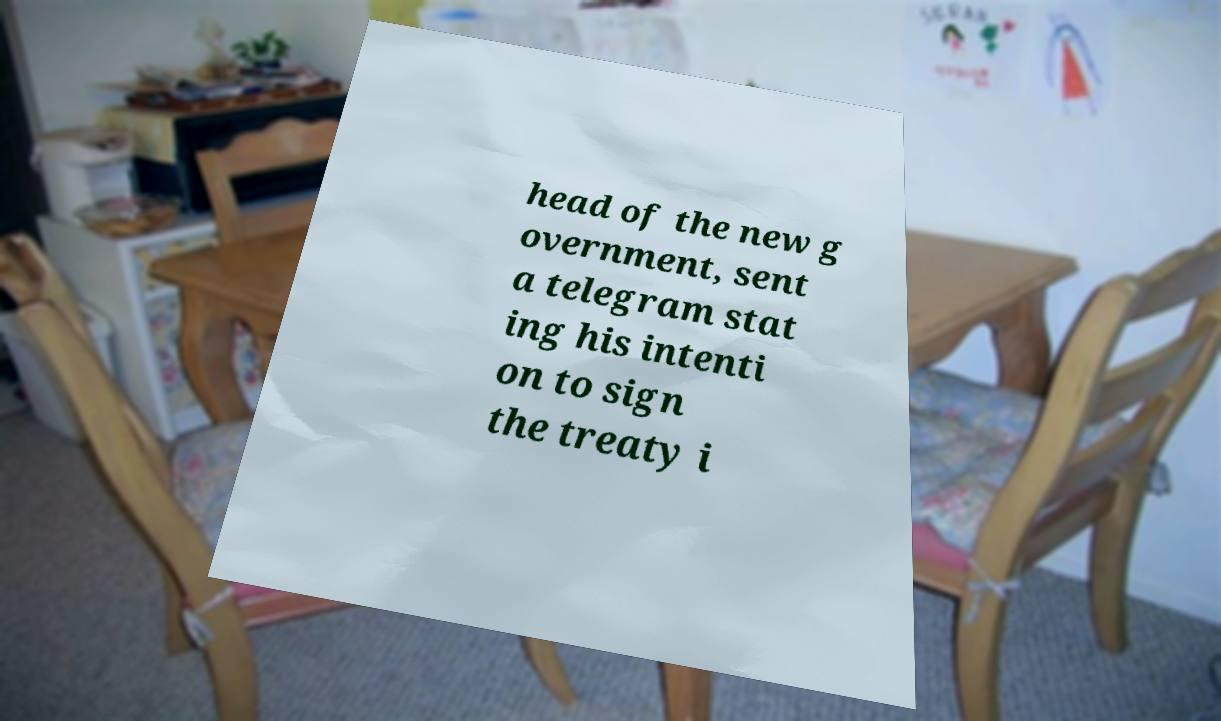There's text embedded in this image that I need extracted. Can you transcribe it verbatim? head of the new g overnment, sent a telegram stat ing his intenti on to sign the treaty i 